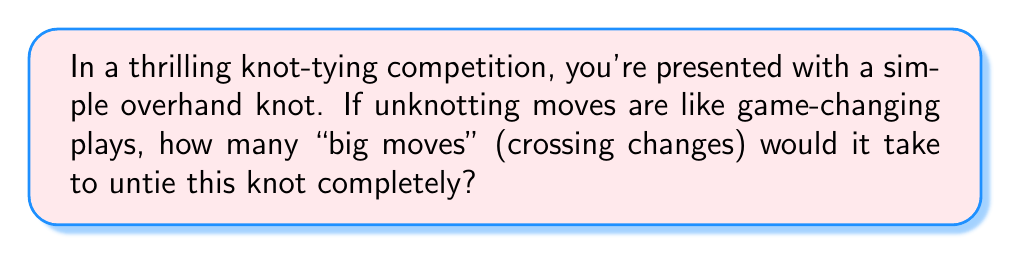Solve this math problem. Let's break this down step-by-step, like analyzing a sports play:

1. First, we need to understand what an overhand knot looks like. It's the simplest non-trivial knot, similar to a basic tie in your shoelace.

2. In knot theory, we represent knots with diagrams. An overhand knot diagram looks like this:

[asy]
import geometry;

path p = (0,0)..(-1,1)..(0,2)..(1,1)..cycle;
draw(p);
draw((0,0.7)--(0,1.3),arrow=Arrow(SimpleHead));
draw((-0.3,1)--(0.3,1),arrow=Arrow(SimpleHead));

label("1", (0.5,0.5));
label("2", (-0.5,1.5));
</asy]

3. The unknotting number is the minimum number of crossing changes needed to transform the knot into the unknot (a simple loop with no crossings).

4. For the overhand knot, we only need to change one crossing to untie it. This is like making one game-changing play to win the match.

5. If we change the crossing labeled "1" in the diagram, the knot will unravel into a simple loop.

6. Mathematically, we can express this as:

   $$u(K_{overhand}) = 1$$

   Where $u(K)$ represents the unknotting number of knot $K$.

7. It's worth noting that while there are other ways to untie the knot (like physically manipulating it), in knot theory, we only consider crossing changes as valid moves.
Answer: 1 